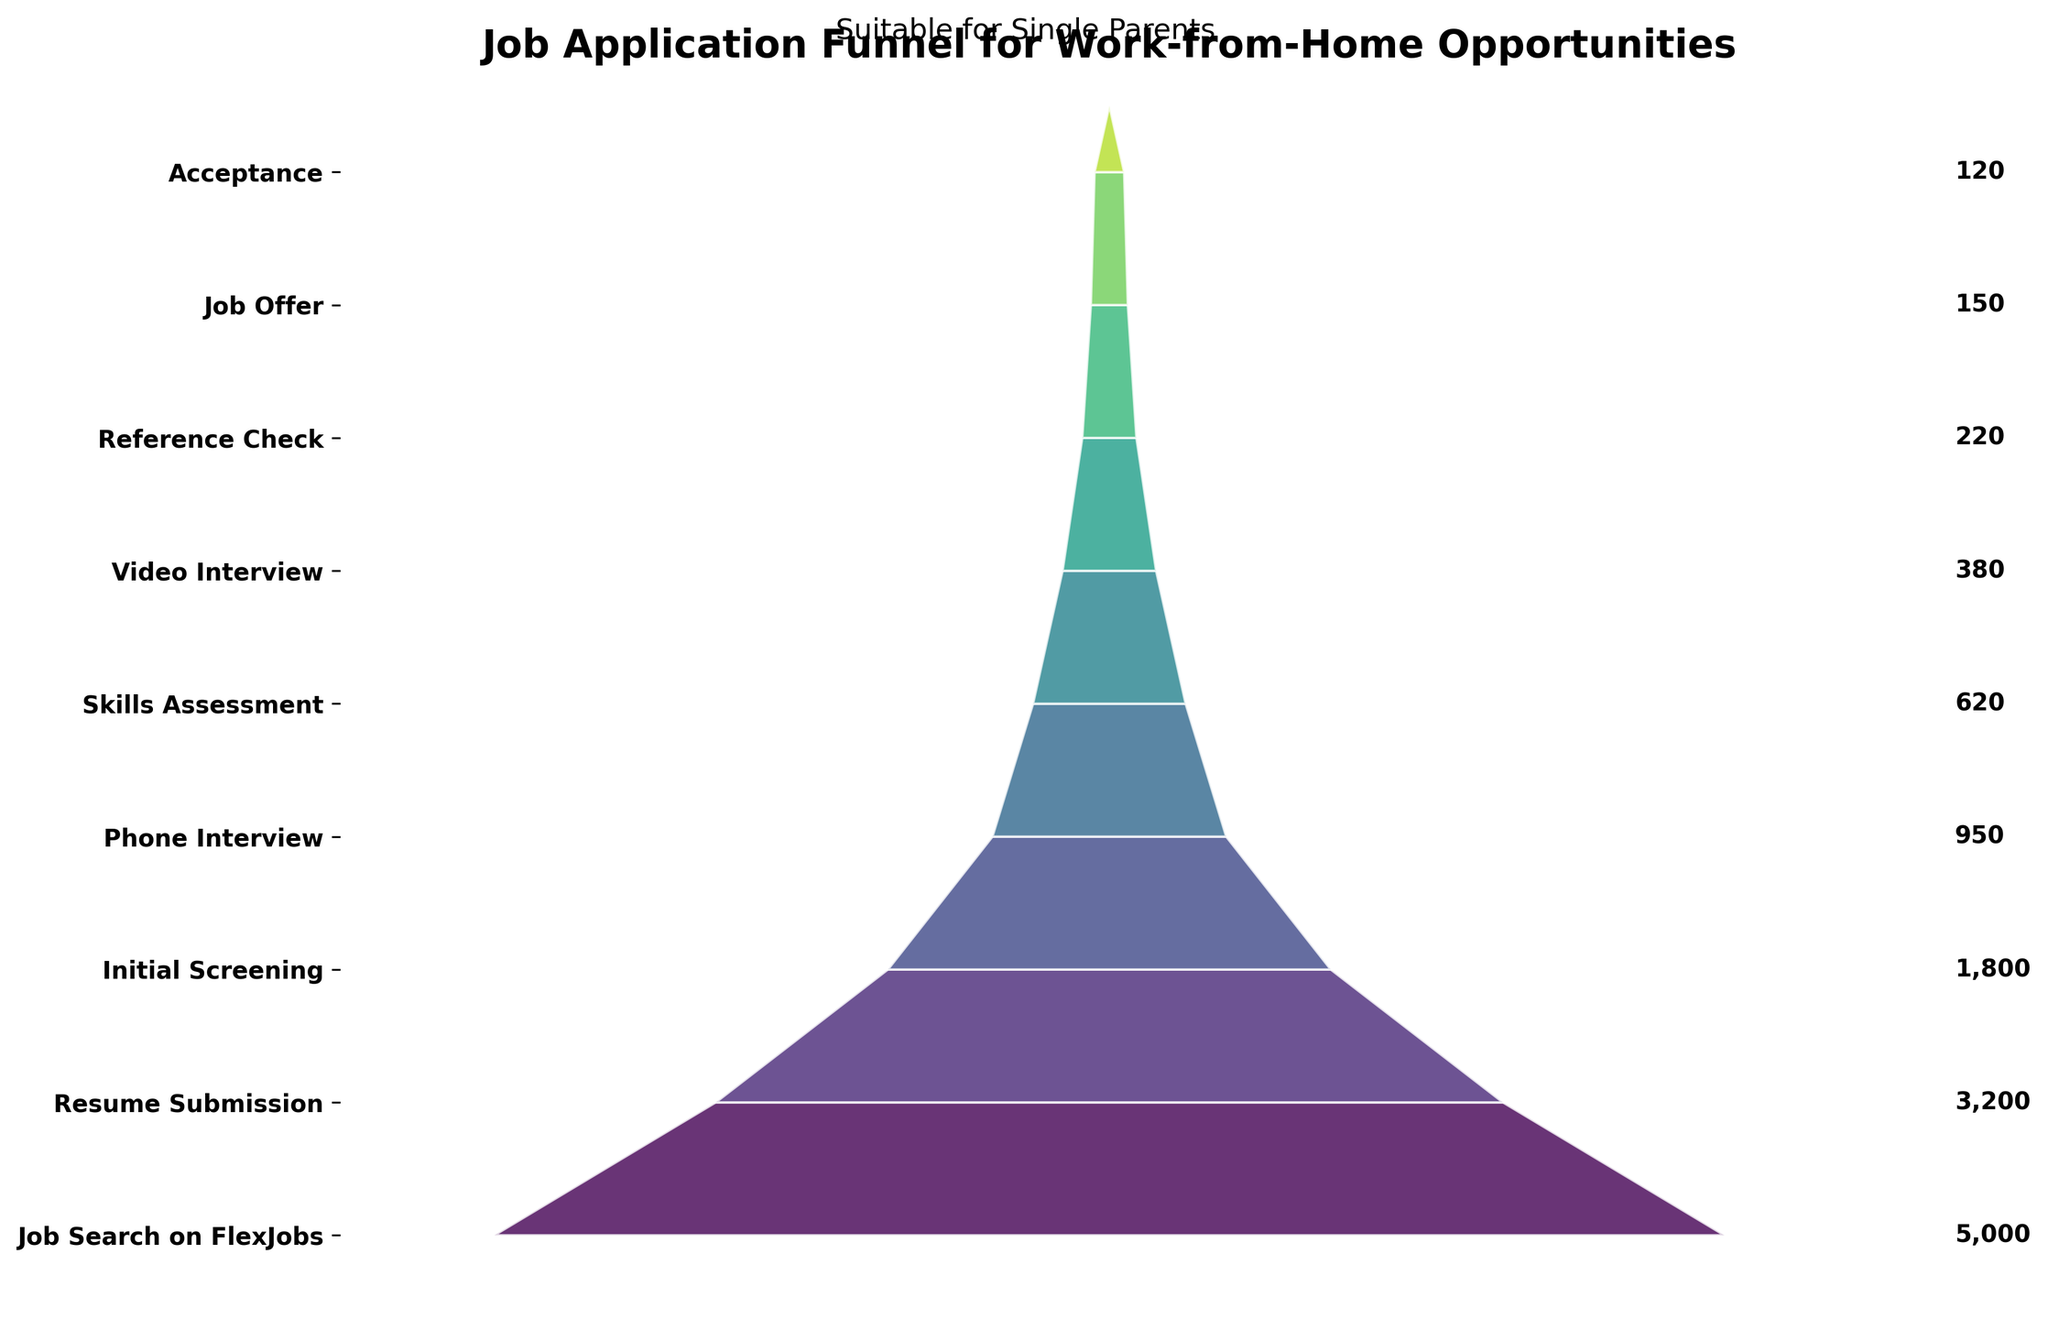How many applicants reached the reference check stage? Looking at the figure, find the "Reference Check" stage on the y-axis and read the corresponding number of applicants.
Answer: 220 Which stage has the highest number of applicants? The highest number of applicants corresponds to the widest part of the funnel, which is labeled at the top of the funnel.
Answer: Job Search on FlexJobs What's the difference in number of applicants between the initial screening and the phone interview stages? Locate "Initial Screening" and "Phone Interview" on the y-axis, and find their corresponding numbers. Subtract the number for "Phone Interview" from "Initial Screening".
Answer: 850 What percentage of applicants who submitted resumes made it to the job offer stage? Find the number of applicants at the "Resume Submission" and "Job Offer" stages. Use the formula (Job Offer / Resume Submission) * 100 to find the percentage.
Answer: 4.69% How many more applicants were there in the skills assessment stage compared to the video interview stage? Locate "Skills Assessment" and "Video Interview" on the y-axis, and find their corresponding numbers. Subtract the number for "Video Interview" from "Skills Assessment".
Answer: 240 What stage sees the largest drop-off in the number of applicants? Compare the differences in the number of applicants between consecutive stages. The largest difference indicates the stage with the largest drop-off.
Answer: Resume Submission to Initial Screening At which stage do less than 25% of the original applicants remain? Starting with the initial number of applicants (5000), calculate 25% of this number which is 1250. Then, identify the stage where the number of applicants falls below 1250 for the first time.
Answer: Phone Interview Which stages have fewer than 500 applicants? Find and list the stages where the number of applicants is below 500 from the funnel chart.
Answer: Video Interview, Reference Check, Job Offer, Acceptance 